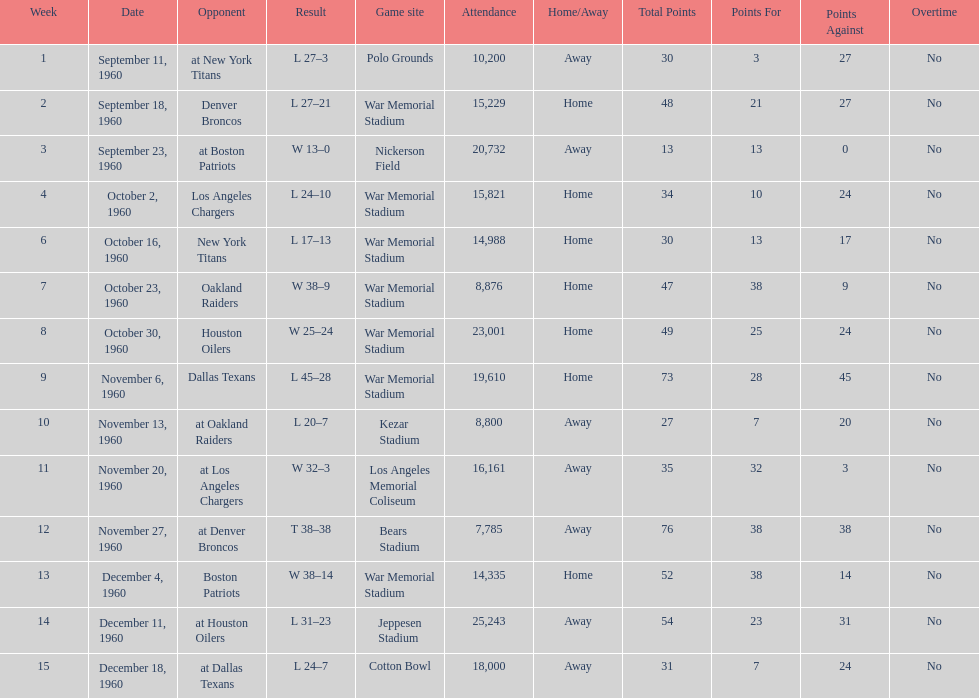Which date had the highest attendance? December 11, 1960. 